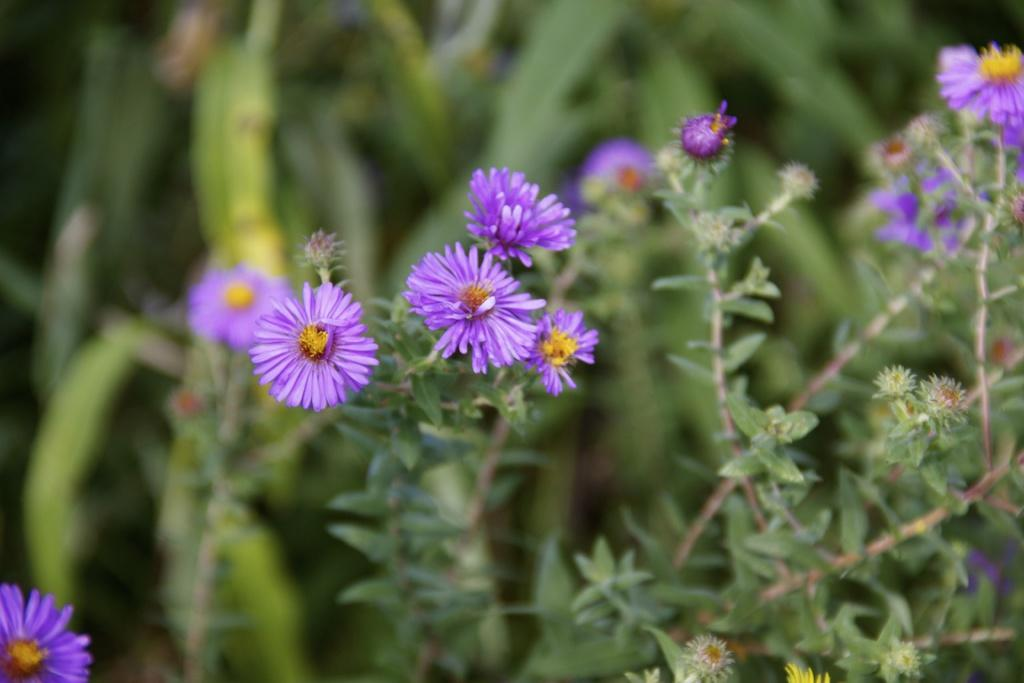What type of plants can be seen in the image? There are flower plants in the image. What color are the flowers on the plants? The flowers are purple in color. Can you describe the background of the image? The background of the image is blurred. What type of collar can be seen on the tongue of the flower in the image? There is no tongue or collar present in the image; it features flower plants with purple flowers. How many bushes are visible in the image? There is no mention of bushes in the provided facts, so it cannot be determined from the image. 